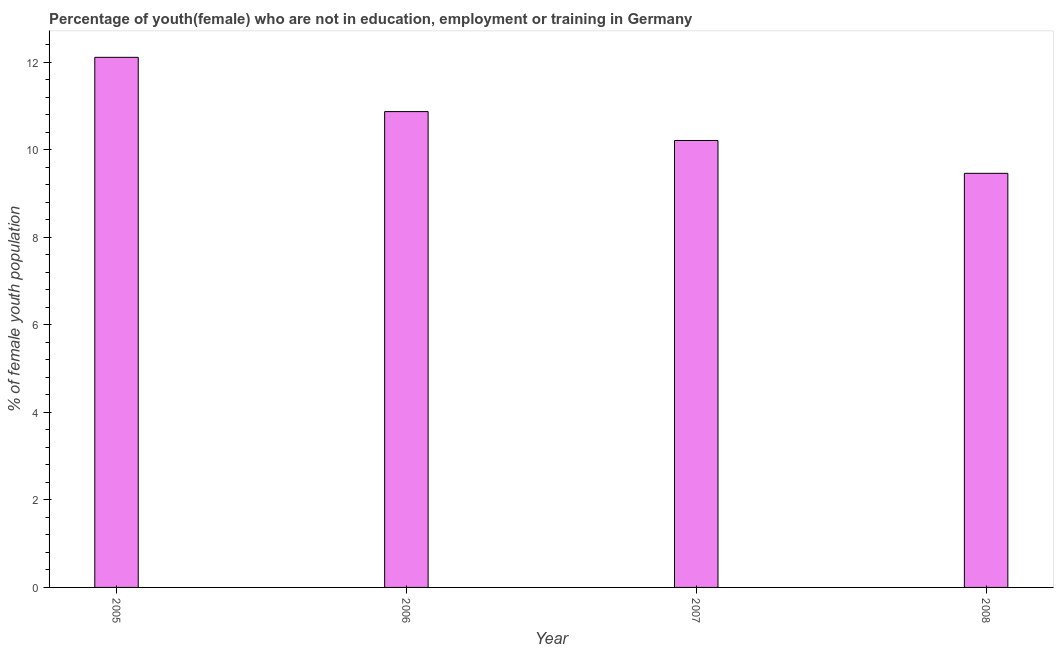Does the graph contain grids?
Offer a very short reply. No. What is the title of the graph?
Your answer should be very brief. Percentage of youth(female) who are not in education, employment or training in Germany. What is the label or title of the Y-axis?
Your answer should be very brief. % of female youth population. What is the unemployed female youth population in 2006?
Your answer should be compact. 10.87. Across all years, what is the maximum unemployed female youth population?
Offer a very short reply. 12.11. Across all years, what is the minimum unemployed female youth population?
Offer a terse response. 9.46. In which year was the unemployed female youth population minimum?
Make the answer very short. 2008. What is the sum of the unemployed female youth population?
Provide a short and direct response. 42.65. What is the difference between the unemployed female youth population in 2006 and 2008?
Make the answer very short. 1.41. What is the average unemployed female youth population per year?
Your answer should be compact. 10.66. What is the median unemployed female youth population?
Ensure brevity in your answer.  10.54. What is the ratio of the unemployed female youth population in 2005 to that in 2006?
Your answer should be very brief. 1.11. Is the unemployed female youth population in 2006 less than that in 2008?
Provide a succinct answer. No. What is the difference between the highest and the second highest unemployed female youth population?
Your answer should be very brief. 1.24. What is the difference between the highest and the lowest unemployed female youth population?
Keep it short and to the point. 2.65. Are all the bars in the graph horizontal?
Give a very brief answer. No. What is the difference between two consecutive major ticks on the Y-axis?
Give a very brief answer. 2. Are the values on the major ticks of Y-axis written in scientific E-notation?
Your answer should be very brief. No. What is the % of female youth population of 2005?
Make the answer very short. 12.11. What is the % of female youth population in 2006?
Your response must be concise. 10.87. What is the % of female youth population in 2007?
Make the answer very short. 10.21. What is the % of female youth population of 2008?
Give a very brief answer. 9.46. What is the difference between the % of female youth population in 2005 and 2006?
Offer a very short reply. 1.24. What is the difference between the % of female youth population in 2005 and 2007?
Ensure brevity in your answer.  1.9. What is the difference between the % of female youth population in 2005 and 2008?
Offer a terse response. 2.65. What is the difference between the % of female youth population in 2006 and 2007?
Your response must be concise. 0.66. What is the difference between the % of female youth population in 2006 and 2008?
Provide a short and direct response. 1.41. What is the difference between the % of female youth population in 2007 and 2008?
Offer a terse response. 0.75. What is the ratio of the % of female youth population in 2005 to that in 2006?
Ensure brevity in your answer.  1.11. What is the ratio of the % of female youth population in 2005 to that in 2007?
Your answer should be compact. 1.19. What is the ratio of the % of female youth population in 2005 to that in 2008?
Ensure brevity in your answer.  1.28. What is the ratio of the % of female youth population in 2006 to that in 2007?
Your response must be concise. 1.06. What is the ratio of the % of female youth population in 2006 to that in 2008?
Ensure brevity in your answer.  1.15. What is the ratio of the % of female youth population in 2007 to that in 2008?
Offer a terse response. 1.08. 